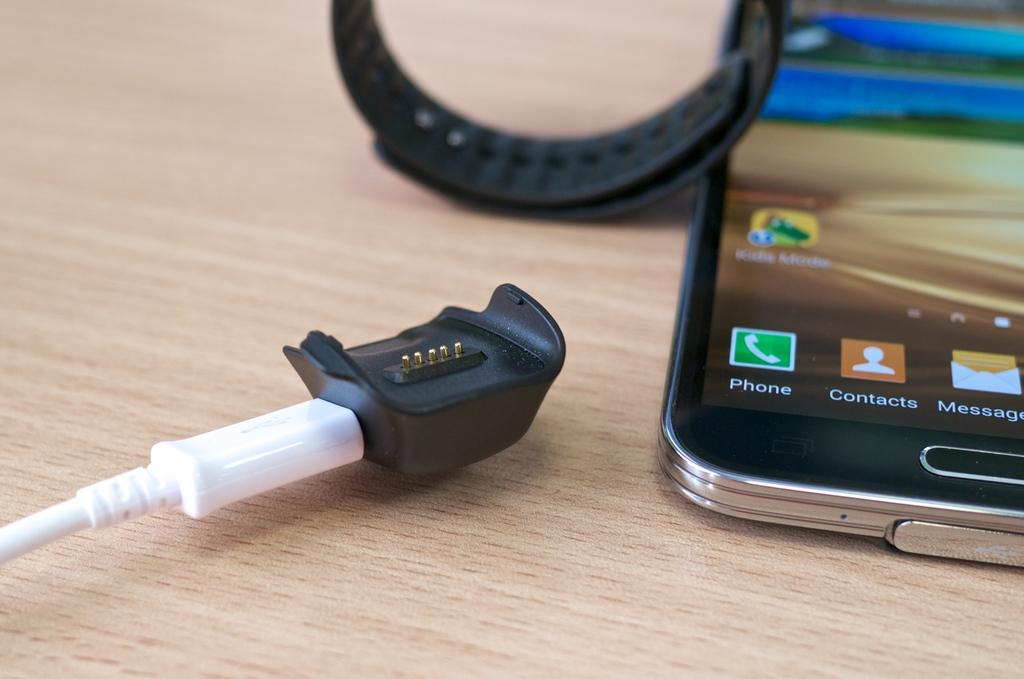<image>
Summarize the visual content of the image. a cell phone with icons for contacts and messages 